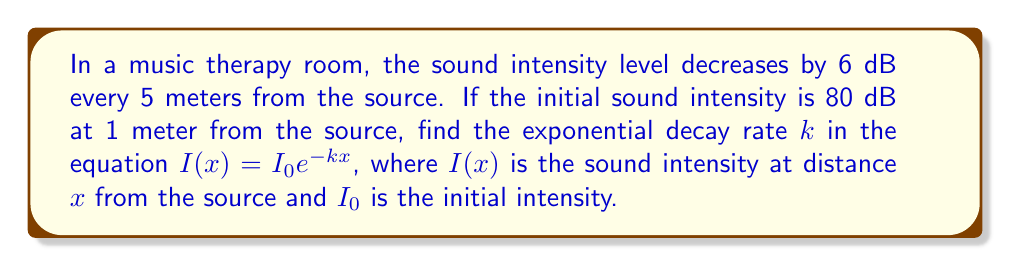Solve this math problem. To solve this problem, we'll follow these steps:

1) The general form of exponential decay is:
   $$I(x) = I_0e^{-kx}$$

2) We're given that the intensity decreases by 6 dB every 5 meters. Let's use this information:
   $$I(5) = I_0e^{-5k} = I_0 \cdot 10^{-6/20}$$

   (The factor of 1/20 comes from the definition of decibels: a decrease of 6 dB corresponds to multiplying the intensity by $10^{-6/20}$)

3) Dividing both sides by $I_0$:
   $$e^{-5k} = 10^{-6/20} = (10^{-1/20})^6 \approx 0.5012$$

4) Taking the natural log of both sides:
   $$-5k = \ln(0.5012)$$

5) Solving for $k$:
   $$k = -\frac{\ln(0.5012)}{5} \approx 0.1386$$

Thus, the exponential decay rate $k$ is approximately 0.1386 per meter.
Answer: $k \approx 0.1386$ m$^{-1}$ 